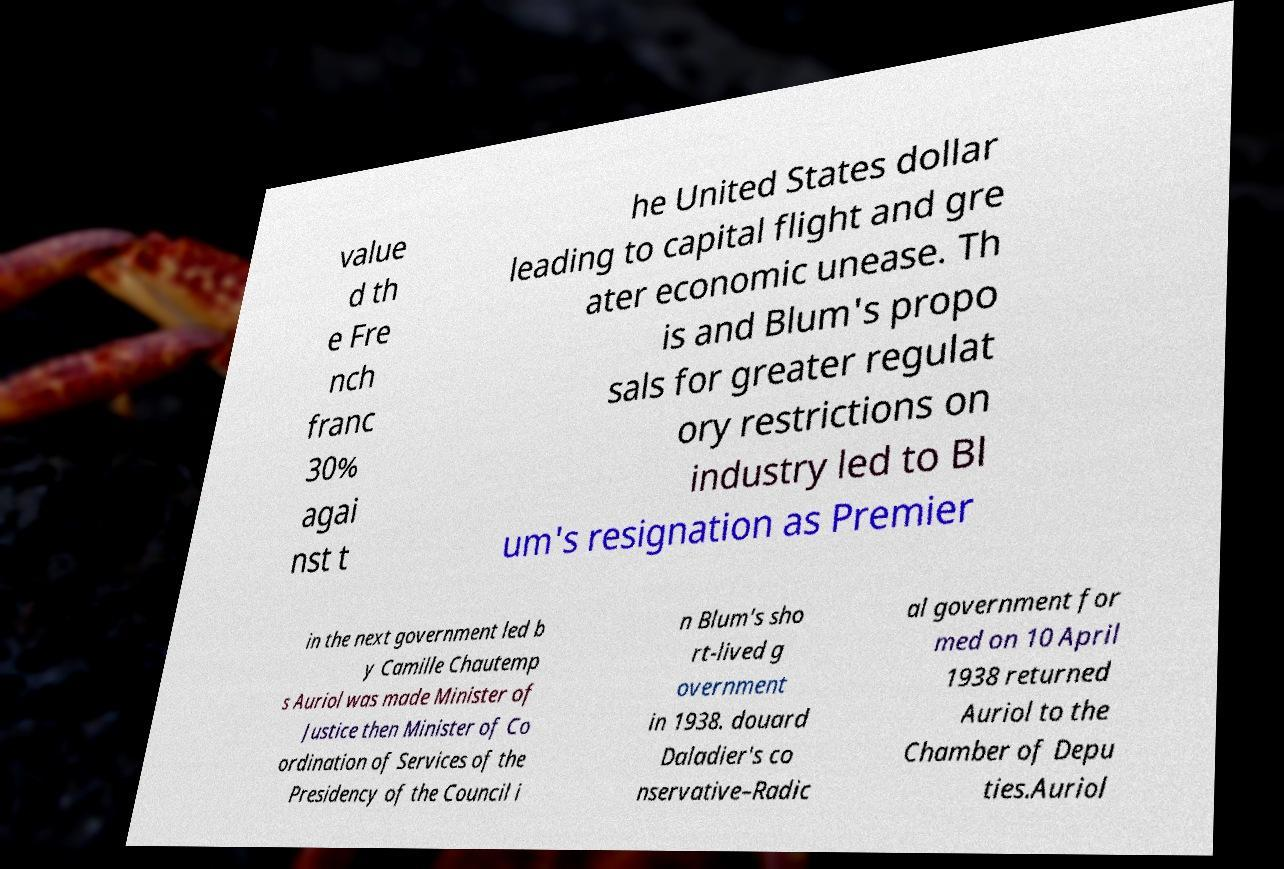For documentation purposes, I need the text within this image transcribed. Could you provide that? value d th e Fre nch franc 30% agai nst t he United States dollar leading to capital flight and gre ater economic unease. Th is and Blum's propo sals for greater regulat ory restrictions on industry led to Bl um's resignation as Premier in the next government led b y Camille Chautemp s Auriol was made Minister of Justice then Minister of Co ordination of Services of the Presidency of the Council i n Blum's sho rt-lived g overnment in 1938. douard Daladier's co nservative–Radic al government for med on 10 April 1938 returned Auriol to the Chamber of Depu ties.Auriol 